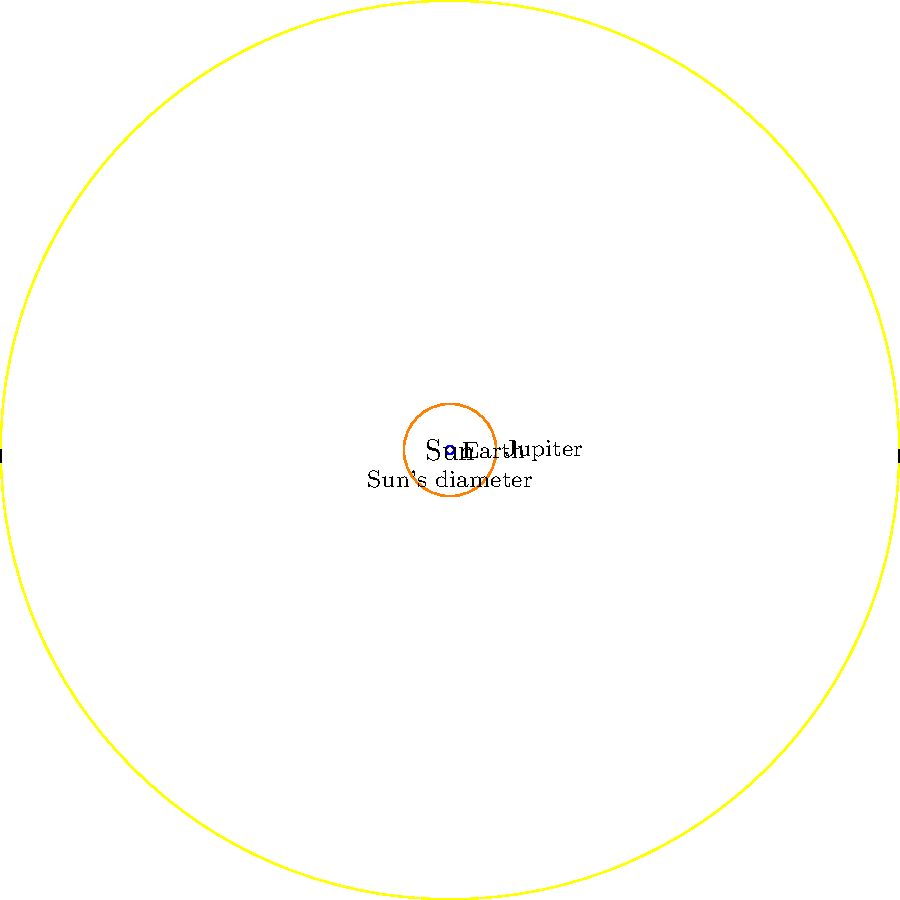In this scaled representation of celestial bodies, how many times larger is the diameter of Jupiter compared to Earth's diameter? Consider the historical context of how this knowledge has evolved since ancient times and its impact on our understanding of the universe. To answer this question, let's follow these steps:

1. Historical context: In ancient times, celestial bodies were often thought to be perfect spheres of various sizes. The true scale of the solar system was unknown until the scientific revolution.

2. Observation: In the diagram, we can see three circles representing the Sun, Jupiter, and Earth, with Earth being the smallest.

3. Given information: The diagram is drawn to scale, meaning the relative sizes of the circles accurately represent the relative sizes of the celestial bodies.

4. Measurement: We need to compare the diameters of Jupiter and Earth. The diameter is twice the radius.

5. Calculation:
   - Earth's diameter = 2 * Earth's radius = 2 * 1 = 2 units
   - Jupiter's diameter = 2 * Jupiter's radius = 2 * 11.2 = 22.4 units

6. Comparison: To find how many times larger Jupiter's diameter is, we divide:
   $\frac{\text{Jupiter's diameter}}{\text{Earth's diameter}} = \frac{22.4}{2} = 11.2$

7. Historical significance: This vast difference in size was not fully appreciated until relatively recent times. The ability to accurately measure and compare celestial bodies has greatly influenced our understanding of the universe and our place in it.
Answer: 11.2 times 